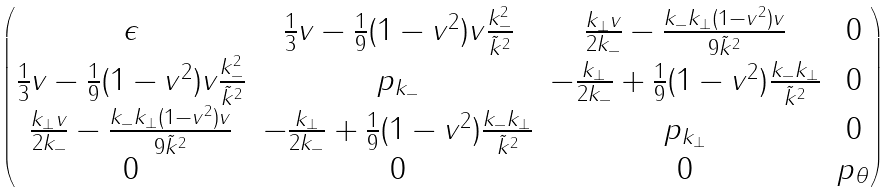Convert formula to latex. <formula><loc_0><loc_0><loc_500><loc_500>\begin{pmatrix} \epsilon & \frac { 1 } { 3 } v - \frac { 1 } { 9 } ( 1 - v ^ { 2 } ) v \frac { k _ { - } ^ { 2 } } { \tilde { k } ^ { 2 } } & \frac { k _ { \bot } v } { 2 k _ { - } } - \frac { k _ { - } k _ { \bot } ( 1 - v ^ { 2 } ) v } { 9 \tilde { k } ^ { 2 } } & 0 \\ \frac { 1 } { 3 } v - \frac { 1 } { 9 } ( 1 - v ^ { 2 } ) v \frac { k _ { - } ^ { 2 } } { \tilde { k } ^ { 2 } } & p _ { k _ { - } } & - \frac { k _ { \bot } } { 2 k _ { - } } + \frac { 1 } { 9 } ( 1 - v ^ { 2 } ) \frac { k _ { - } k _ { \bot } } { \tilde { k } ^ { 2 } } & 0 \\ \frac { k _ { \bot } v } { 2 k _ { - } } - \frac { k _ { - } k _ { \bot } ( 1 - v ^ { 2 } ) v } { 9 \tilde { k } ^ { 2 } } & - \frac { k _ { \bot } } { 2 k _ { - } } + \frac { 1 } { 9 } ( 1 - v ^ { 2 } ) \frac { k _ { - } k _ { \bot } } { \tilde { k } ^ { 2 } } & p _ { k _ { \bot } } & 0 \\ 0 & 0 & 0 & p _ { \theta } \end{pmatrix}</formula> 